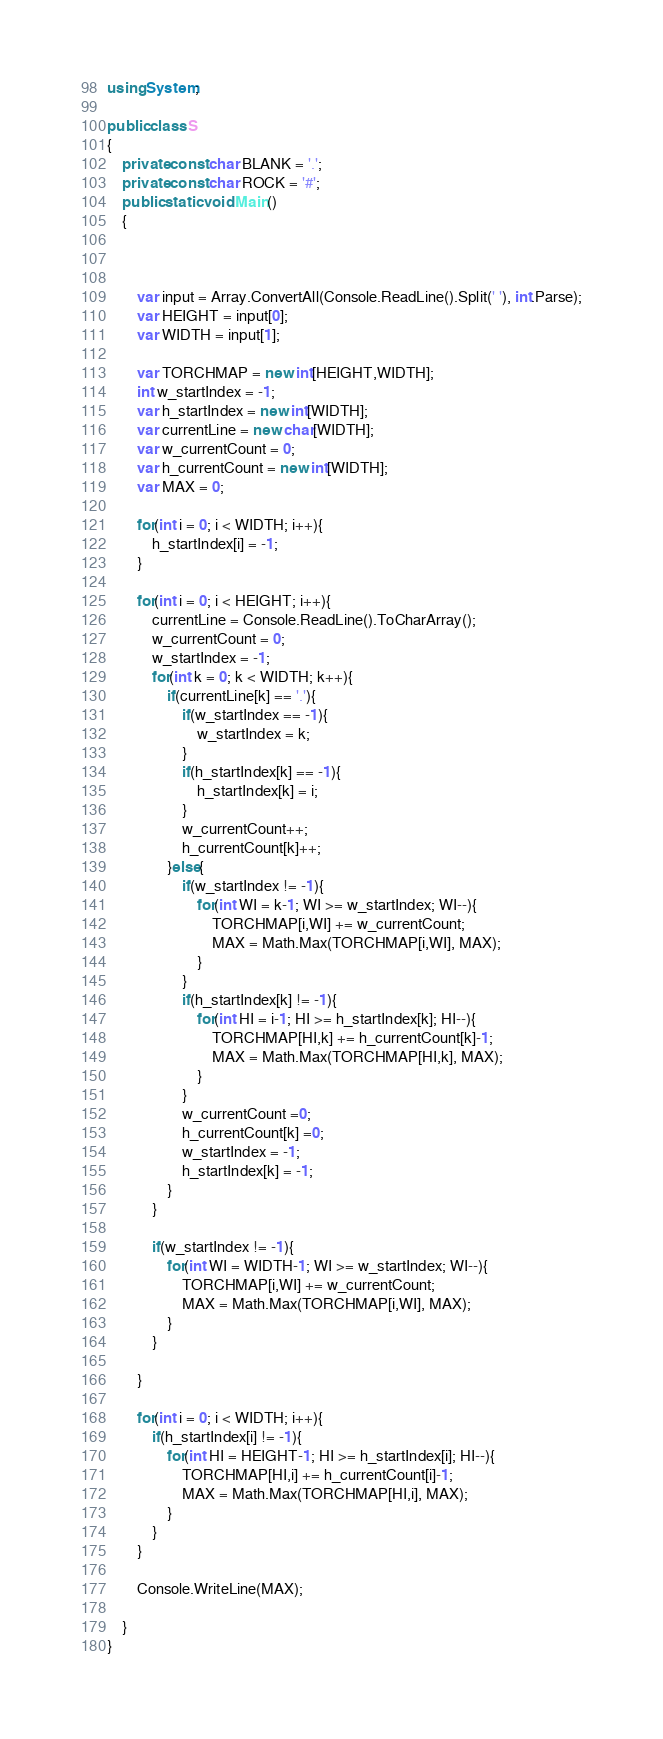Convert code to text. <code><loc_0><loc_0><loc_500><loc_500><_C#_>using System;

public class S
{
    private const char BLANK = '.';
    private const char ROCK = '#';
    public static void Main()
    {



        var input = Array.ConvertAll(Console.ReadLine().Split(' '), int.Parse);
        var HEIGHT = input[0];
        var WIDTH = input[1];

        var TORCHMAP = new int[HEIGHT,WIDTH];
        int w_startIndex = -1;
        var h_startIndex = new int[WIDTH];
        var currentLine = new char[WIDTH];
        var w_currentCount = 0;
        var h_currentCount = new int[WIDTH];
        var MAX = 0;

        for(int i = 0; i < WIDTH; i++){
            h_startIndex[i] = -1;
        }

        for(int i = 0; i < HEIGHT; i++){
            currentLine = Console.ReadLine().ToCharArray();
            w_currentCount = 0;
            w_startIndex = -1;
            for(int k = 0; k < WIDTH; k++){
                if(currentLine[k] == '.'){
                    if(w_startIndex == -1){
                        w_startIndex = k;
                    } 
                    if(h_startIndex[k] == -1){
                        h_startIndex[k] = i;
                    } 
                    w_currentCount++;
                    h_currentCount[k]++;
                }else{
                    if(w_startIndex != -1){
                        for(int WI = k-1; WI >= w_startIndex; WI--){
                            TORCHMAP[i,WI] += w_currentCount;
                            MAX = Math.Max(TORCHMAP[i,WI], MAX);
                        }
                    }
                    if(h_startIndex[k] != -1){
                        for(int HI = i-1; HI >= h_startIndex[k]; HI--){
                            TORCHMAP[HI,k] += h_currentCount[k]-1;
                            MAX = Math.Max(TORCHMAP[HI,k], MAX);
                        }
                    }
                    w_currentCount =0;
                    h_currentCount[k] =0;
                    w_startIndex = -1;
                    h_startIndex[k] = -1;
                }
            }

            if(w_startIndex != -1){
                for(int WI = WIDTH-1; WI >= w_startIndex; WI--){
                    TORCHMAP[i,WI] += w_currentCount;
                    MAX = Math.Max(TORCHMAP[i,WI], MAX);
                }
            }
            
        }

        for(int i = 0; i < WIDTH; i++){
            if(h_startIndex[i] != -1){
                for(int HI = HEIGHT-1; HI >= h_startIndex[i]; HI--){
                    TORCHMAP[HI,i] += h_currentCount[i]-1;
                    MAX = Math.Max(TORCHMAP[HI,i], MAX);
                }
            }
        }

        Console.WriteLine(MAX);

    }
}</code> 